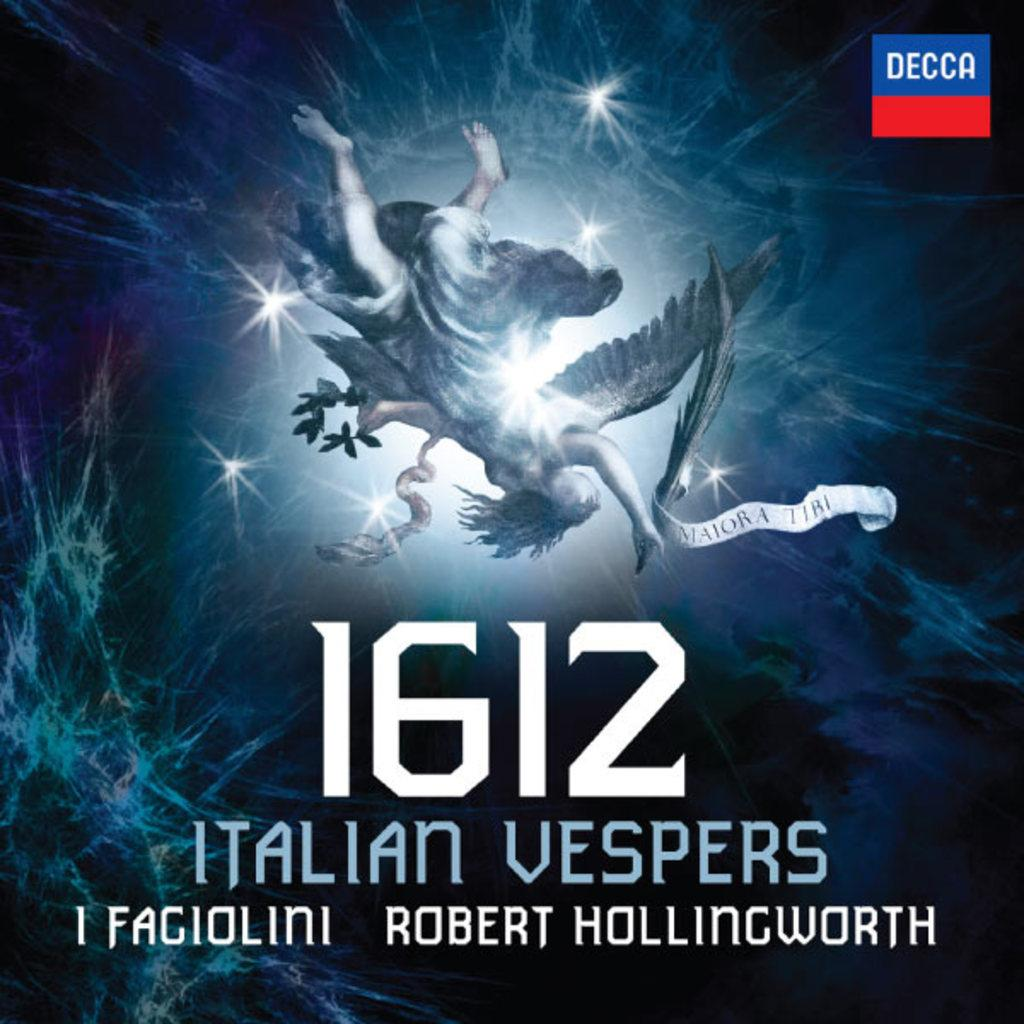<image>
Relay a brief, clear account of the picture shown. a poster that has the year 1612 on it 